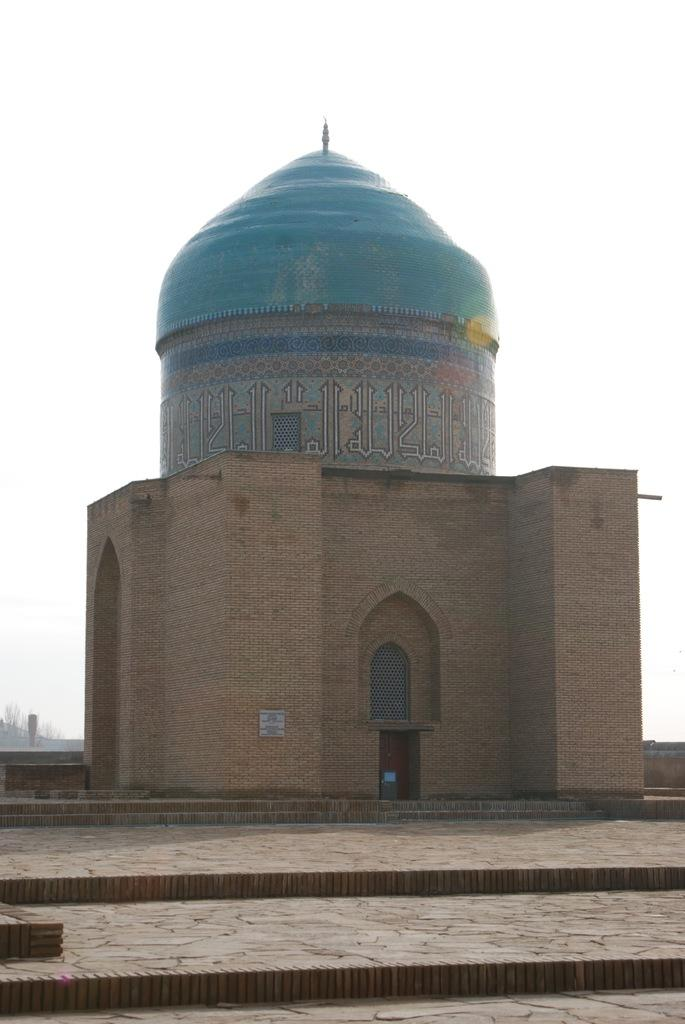What is the main structure in the center of the image? There is a dome in the center of the image. What type of architectural feature is present at the bottom side of the image? There are flat stairs at the bottom side of the image. How many children are being punished in the image? There are no children or any indication of punishment present in the image. 